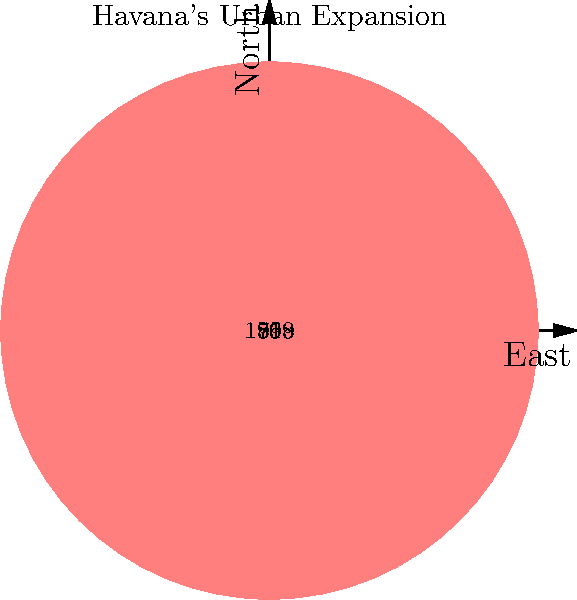Based on the simplified city maps showing Havana's urban expansion, which period saw the most significant growth in the city's area? To determine the period of most significant growth, we need to analyze the expansion between each phase:

1. 1519 to 1763: The city expanded from the innermost circle to the second circle. This represents the initial growth of colonial Havana.

2. 1763 to 1899: The city grew from the second to the third circle. This expansion reflects the period of Spanish colonial rule and increasing prosperity.

3. 1899 to 1958: The city expanded from the third to the outermost circle. This represents the largest increase in area, covering the period from the end of Spanish colonial rule through the early Republican era.

By comparing these expansions, we can see that the period from 1899 to 1958 shows the most significant growth in terms of area covered. This coincides with Havana's rapid modernization and population growth in the early 20th century, fueled by economic development and American investment.
Answer: 1899 to 1958 